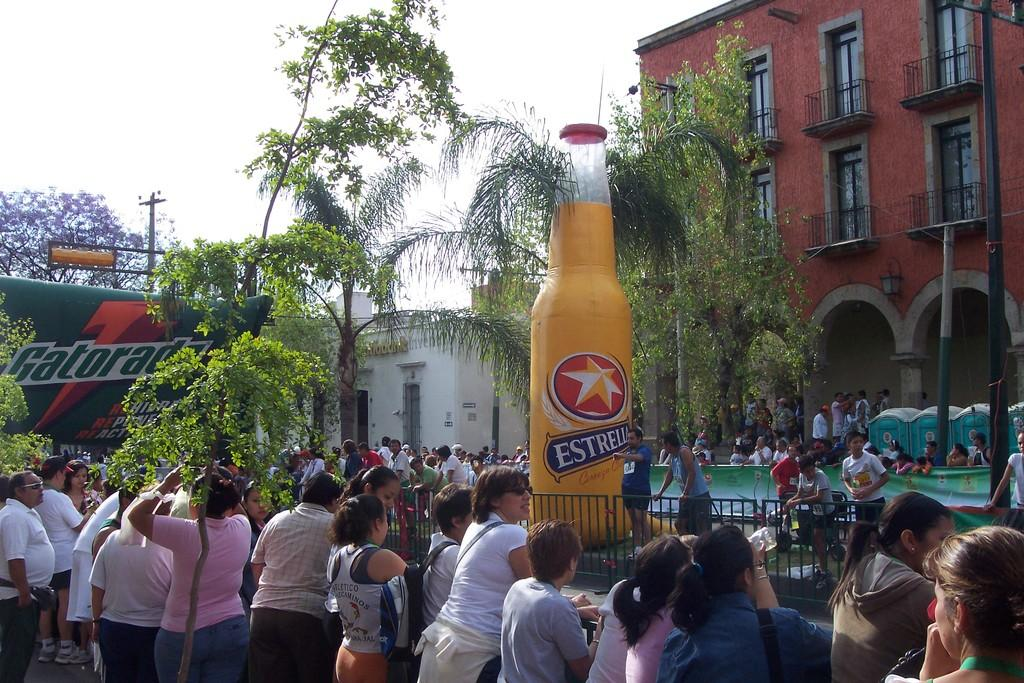<image>
Relay a brief, clear account of the picture shown. People are gathered outdoors at an event that includes a large Gatorade banner and a blow up beer bottle. 